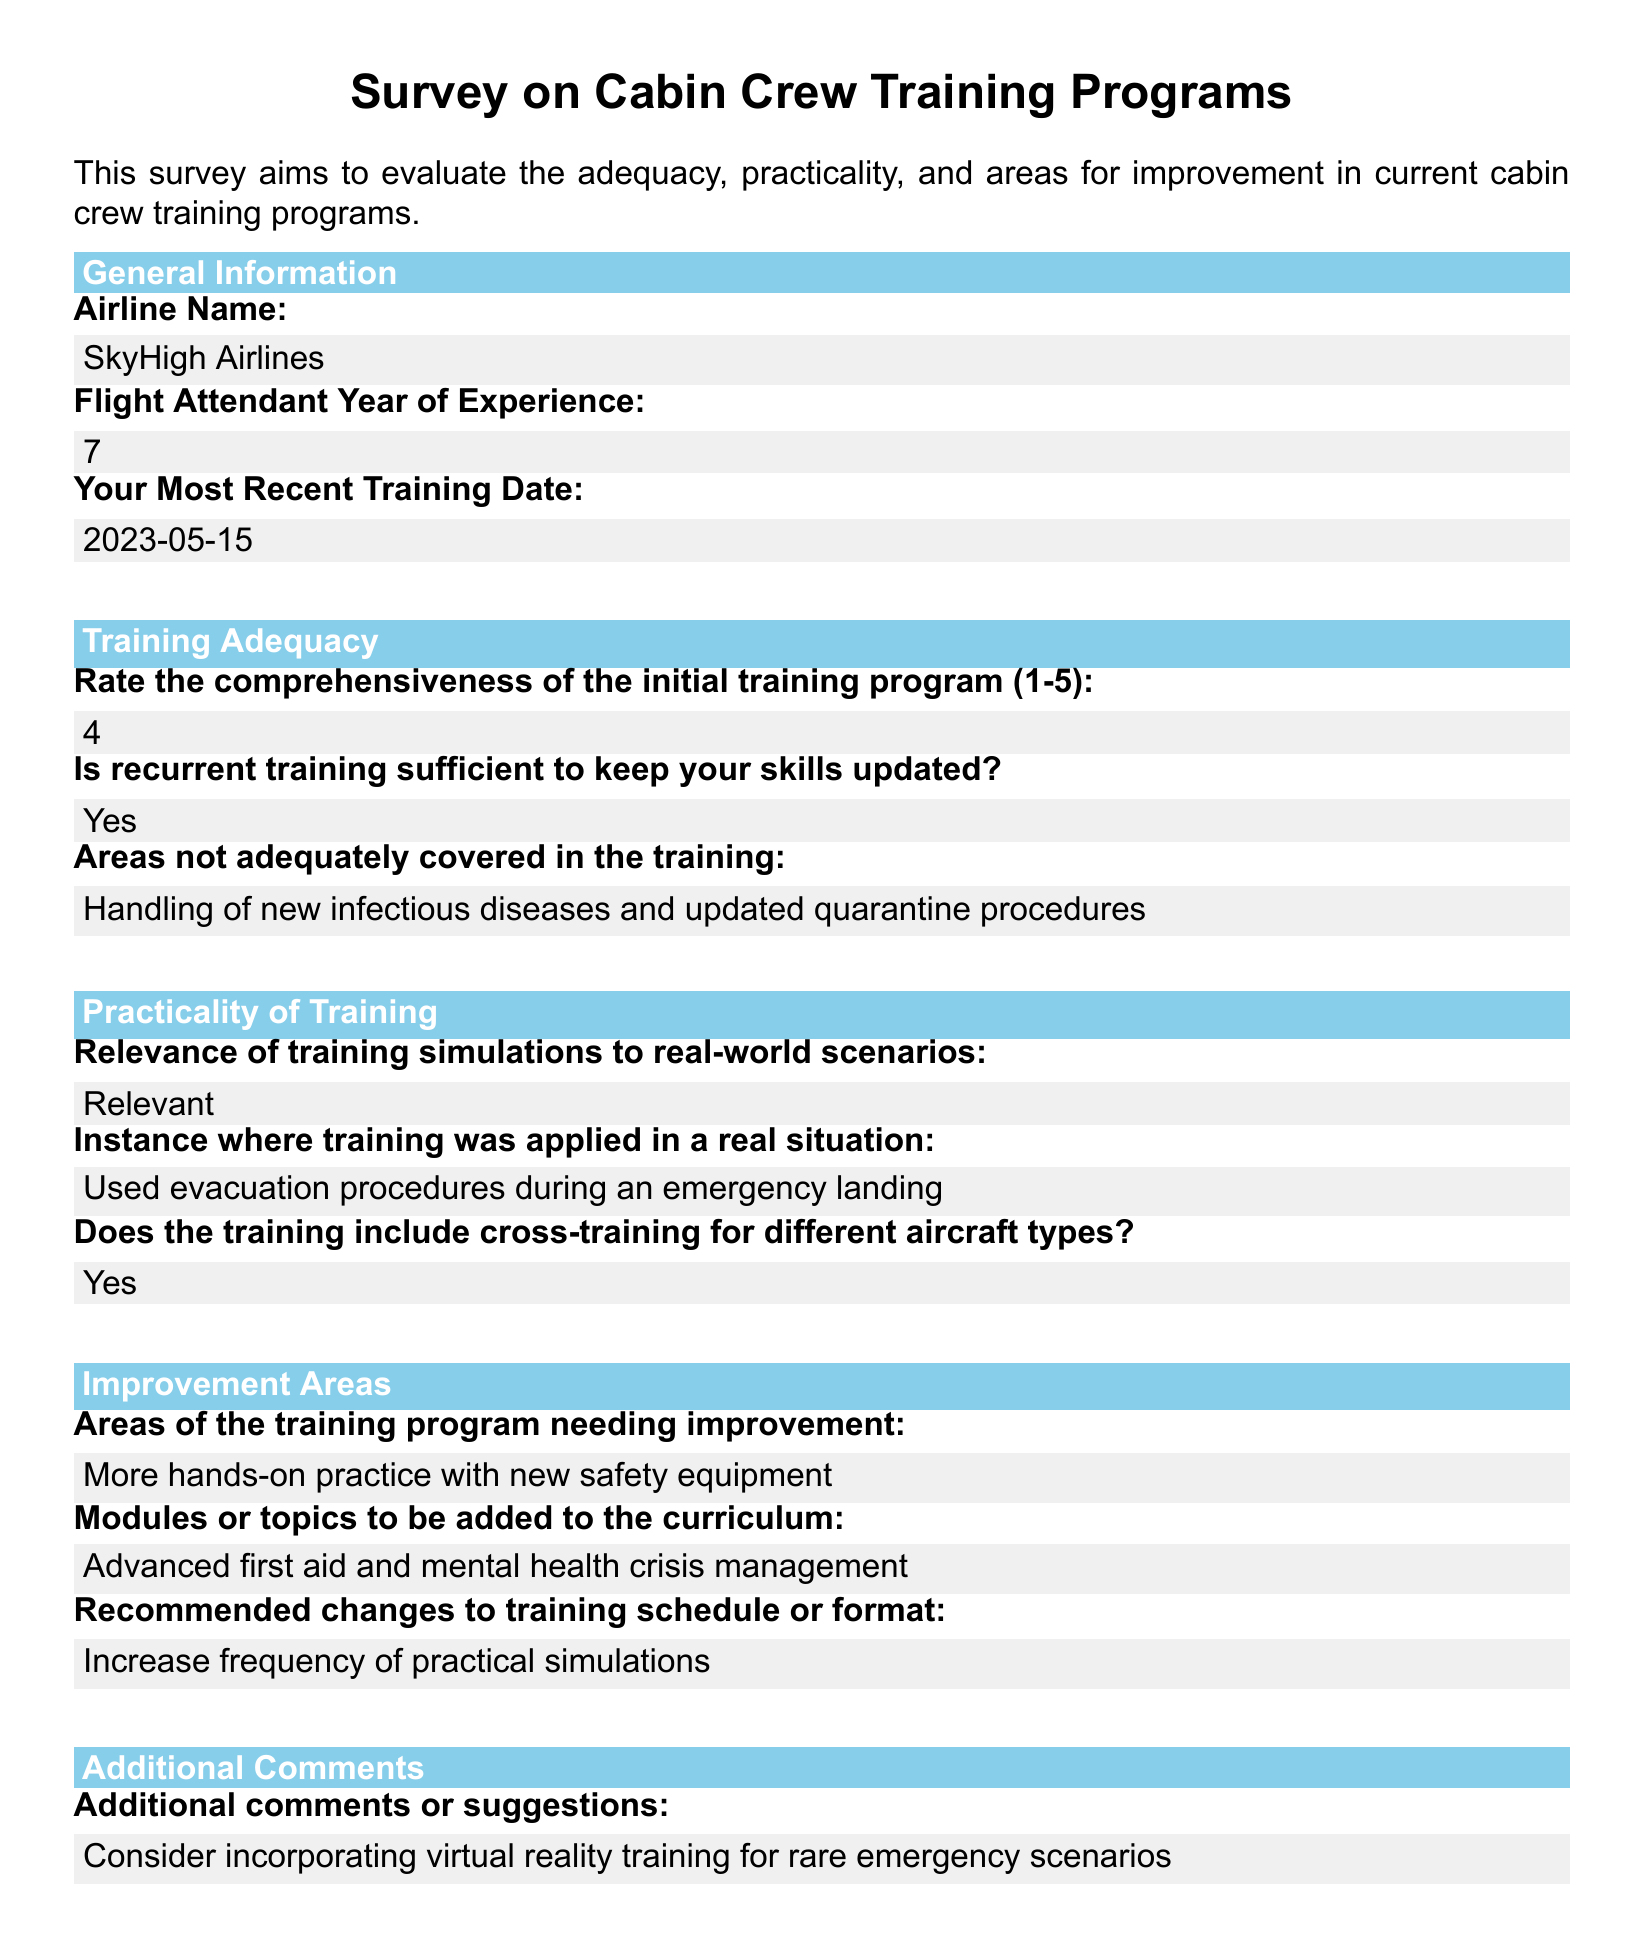What is the name of the airline? The airline name is provided in the general information section of the document.
Answer: SkyHigh Airlines How many years of experience does the flight attendant have? The flight attendant's experience is listed in the general information section of the document.
Answer: 7 On what date was the most recent training conducted? The most recent training date is specified in the general information section of the document.
Answer: 2023-05-15 What rating was given for the comprehensiveness of the initial training program? The rating for the training program comprehensiveness is found in the training adequacy section.
Answer: 4 What is one area not adequately covered in the training? The document mentions areas not properly covered in the training in the training adequacy section.
Answer: Handling of new infectious diseases and updated quarantine procedures What is a suggested module to be added to the curriculum? Recommendations for adding modules are detailed in the improvement areas section of the document.
Answer: Advanced first aid and mental health crisis management What did the flight attendant suggest to improve practical simulations? The flight attendant made a recommendation regarding practical simulations in the improvement areas section.
Answer: Increase frequency of practical simulations Was recurrent training deemed sufficient to keep skills updated? The sufficiency of recurrent training is indicated in the training adequacy section.
Answer: Yes 